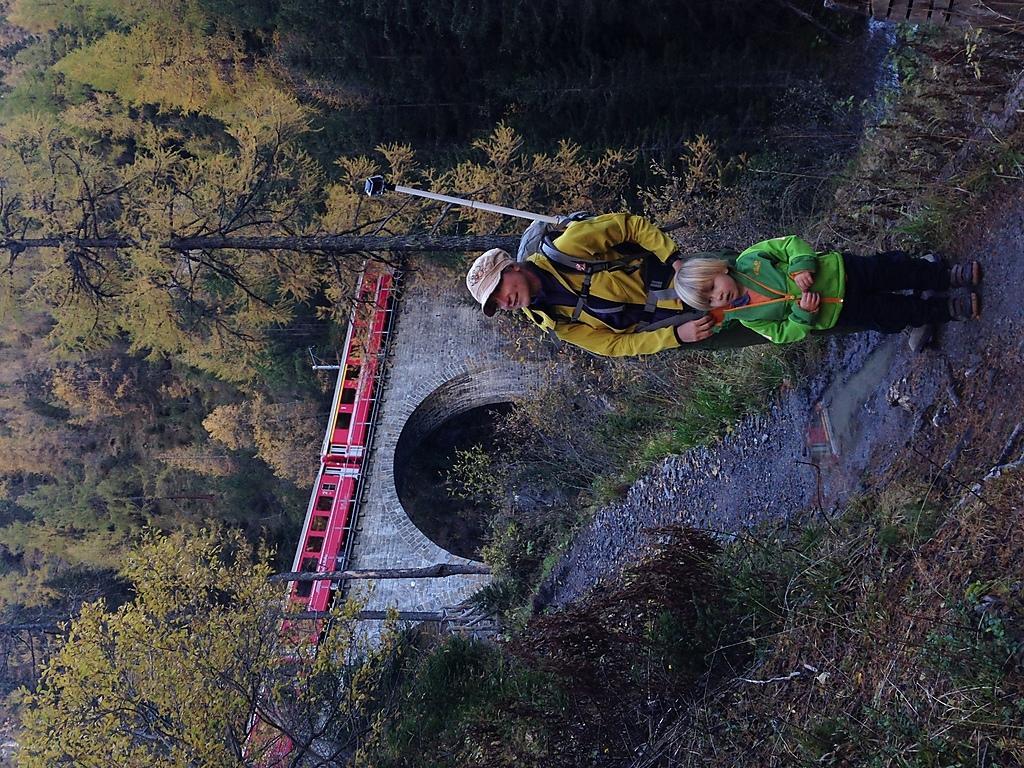Please provide a concise description of this image. In the picture we can see a man and a child standing on the path, a man is wearing a jacket and a bag and a cap, near to them, we can see some grass, plants and a railway bridge and a train on it which is red in color and behind it we can see a tree. 